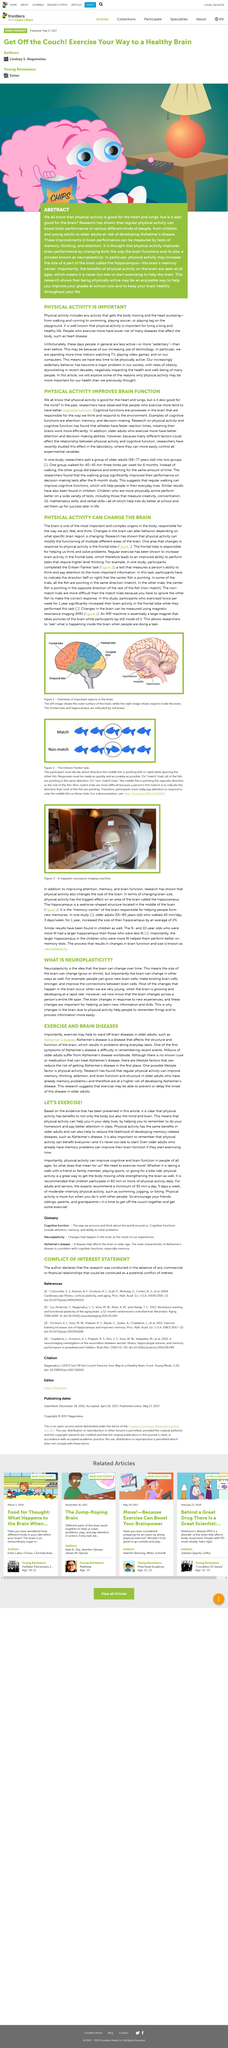Highlight a few significant elements in this photo. Physical activity has numerous benefits, not only for the body but also for the mind and brain. People are more sedentary nowadays due to the widespread use of technology, which has led to a decrease in physical activity. Physical activity is any action that involves movement of the body and results in an increase in heart rate, such as walking, running, or dancing. Physical activity plays a significant role in daily life by aiding in the memory retention of homework and enhancing attention in class. Physical activity in adults is associated with a reduced likelihood of developing memory-related diseases such as Alzheimer's Disease. 